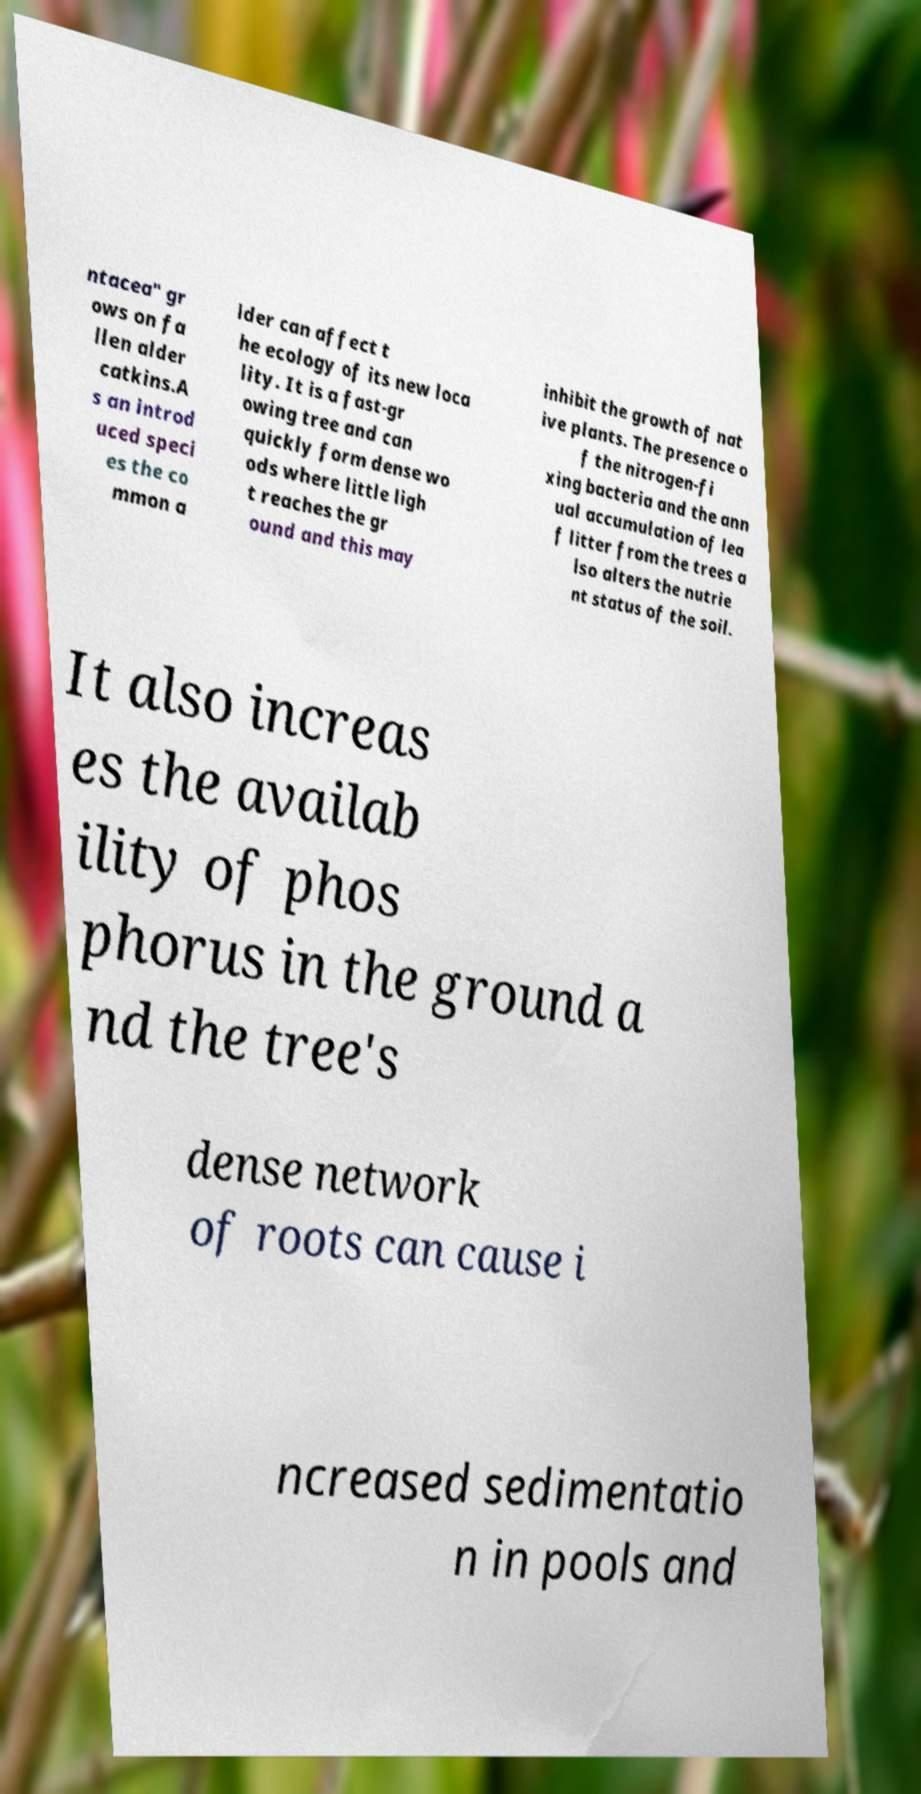Can you read and provide the text displayed in the image?This photo seems to have some interesting text. Can you extract and type it out for me? ntacea" gr ows on fa llen alder catkins.A s an introd uced speci es the co mmon a lder can affect t he ecology of its new loca lity. It is a fast-gr owing tree and can quickly form dense wo ods where little ligh t reaches the gr ound and this may inhibit the growth of nat ive plants. The presence o f the nitrogen-fi xing bacteria and the ann ual accumulation of lea f litter from the trees a lso alters the nutrie nt status of the soil. It also increas es the availab ility of phos phorus in the ground a nd the tree's dense network of roots can cause i ncreased sedimentatio n in pools and 